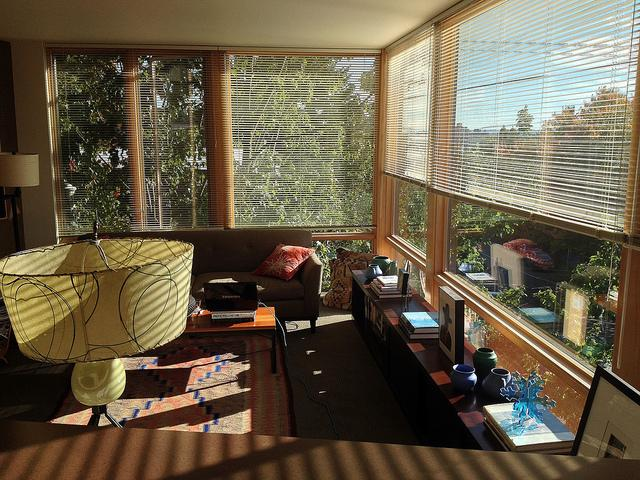How many items in the living room may have to share an outlet with the laptop? Please explain your reasoning. two. There appears to be two electronics in the room that could potentially share an outlet with the laptop. 